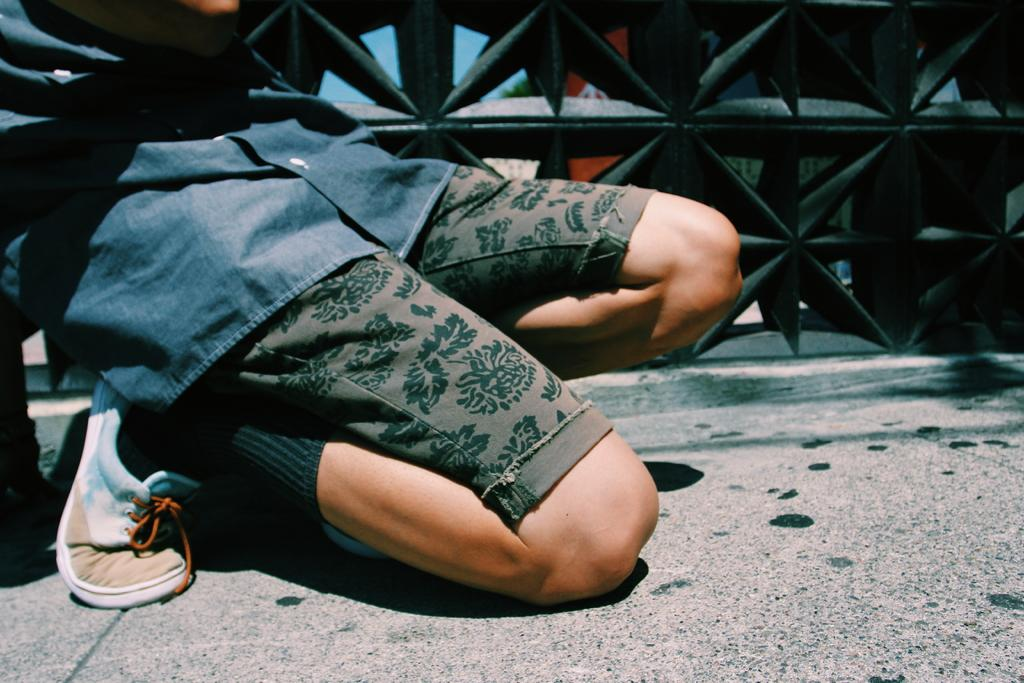What is the man in the image doing? The man is sitting on his knees in the image. What can be seen at the bottom of the image? There is a road at the bottom of the image. What color is the railing in the background of the image? The railing in the background of the image is black. What color is the man's shirt in the image? The man is wearing a blue shirt. How many sisters does the man have in the image? There is no information about the man's sisters in the image. What type of trains can be seen passing by in the image? There are no trains visible in the image. 